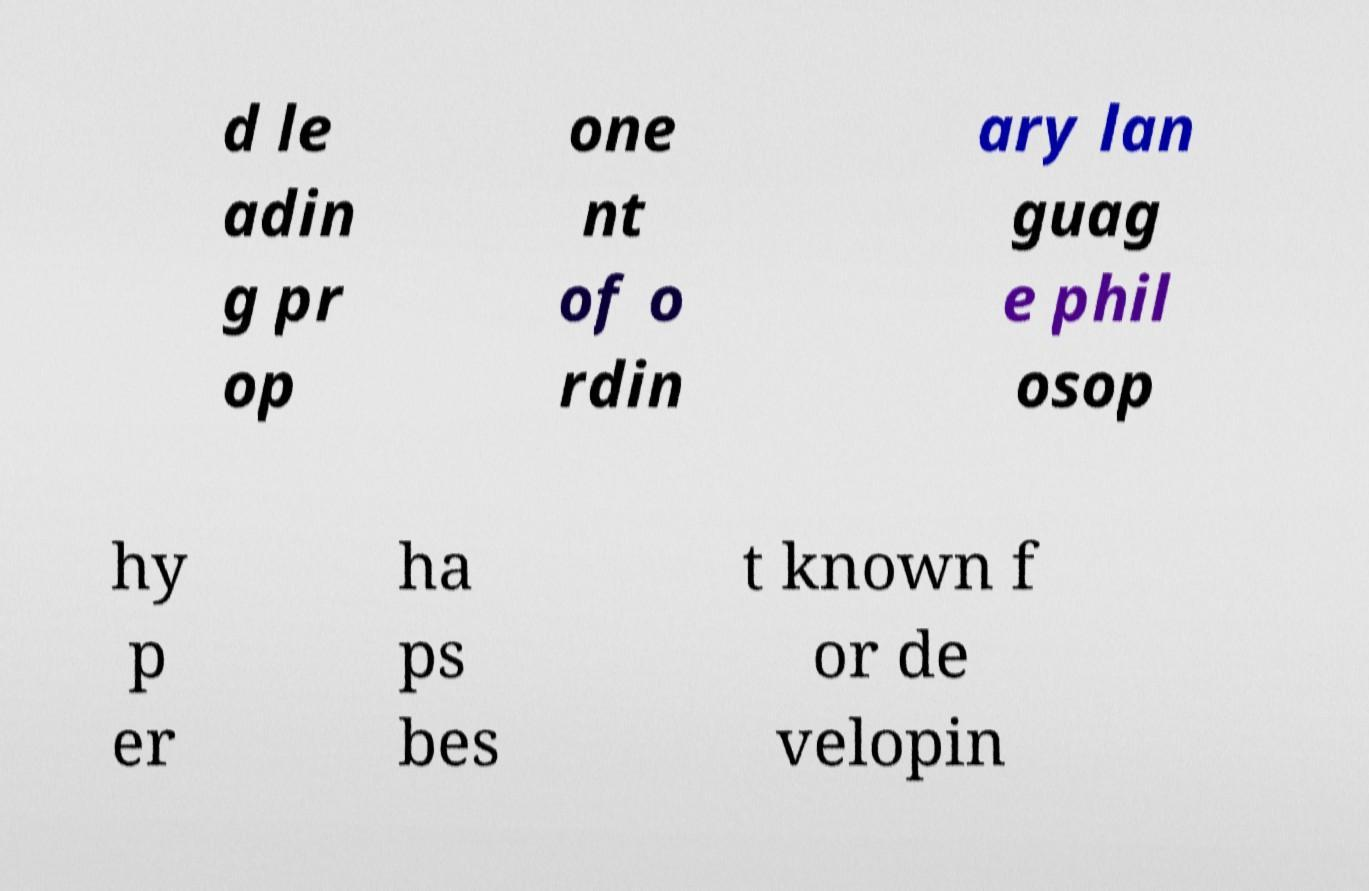Can you accurately transcribe the text from the provided image for me? d le adin g pr op one nt of o rdin ary lan guag e phil osop hy p er ha ps bes t known f or de velopin 